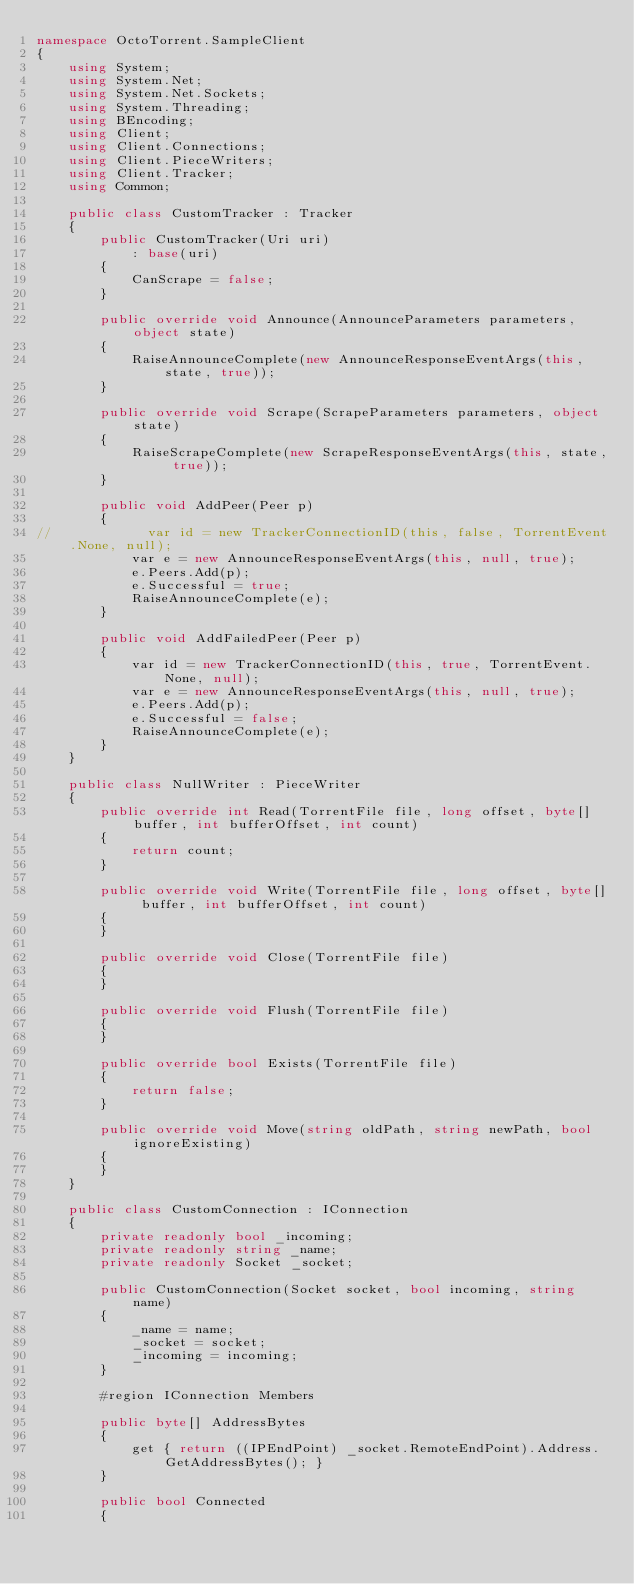<code> <loc_0><loc_0><loc_500><loc_500><_C#_>namespace OctoTorrent.SampleClient
{
    using System;
    using System.Net;
    using System.Net.Sockets;
    using System.Threading;
    using BEncoding;
    using Client;
    using Client.Connections;
    using Client.PieceWriters;
    using Client.Tracker;
    using Common;

    public class CustomTracker : Tracker
    {
        public CustomTracker(Uri uri)
            : base(uri)
        {
            CanScrape = false;
        }

        public override void Announce(AnnounceParameters parameters, object state)
        {
            RaiseAnnounceComplete(new AnnounceResponseEventArgs(this, state, true));
        }

        public override void Scrape(ScrapeParameters parameters, object state)
        {
            RaiseScrapeComplete(new ScrapeResponseEventArgs(this, state, true));
        }

        public void AddPeer(Peer p)
        {
//            var id = new TrackerConnectionID(this, false, TorrentEvent.None, null);
            var e = new AnnounceResponseEventArgs(this, null, true);
            e.Peers.Add(p);
            e.Successful = true;
            RaiseAnnounceComplete(e);
        }

        public void AddFailedPeer(Peer p)
        {
            var id = new TrackerConnectionID(this, true, TorrentEvent.None, null);
            var e = new AnnounceResponseEventArgs(this, null, true);
            e.Peers.Add(p);
            e.Successful = false;
            RaiseAnnounceComplete(e);
        }
    }

    public class NullWriter : PieceWriter
    {
        public override int Read(TorrentFile file, long offset, byte[] buffer, int bufferOffset, int count)
        {
            return count;
        }

        public override void Write(TorrentFile file, long offset, byte[] buffer, int bufferOffset, int count)
        {
        }

        public override void Close(TorrentFile file)
        {
        }

        public override void Flush(TorrentFile file)
        {
        }

        public override bool Exists(TorrentFile file)
        {
            return false;
        }

        public override void Move(string oldPath, string newPath, bool ignoreExisting)
        {
        }
    }

    public class CustomConnection : IConnection
    {
        private readonly bool _incoming;
        private readonly string _name;
        private readonly Socket _socket;

        public CustomConnection(Socket socket, bool incoming, string name)
        {
            _name = name;
            _socket = socket;
            _incoming = incoming;
        }

        #region IConnection Members

        public byte[] AddressBytes
        {
            get { return ((IPEndPoint) _socket.RemoteEndPoint).Address.GetAddressBytes(); }
        }

        public bool Connected
        {</code> 